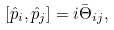<formula> <loc_0><loc_0><loc_500><loc_500>[ \hat { p } _ { i } , \hat { p } _ { j } ] = i \bar { \Theta } _ { i j } ,</formula> 